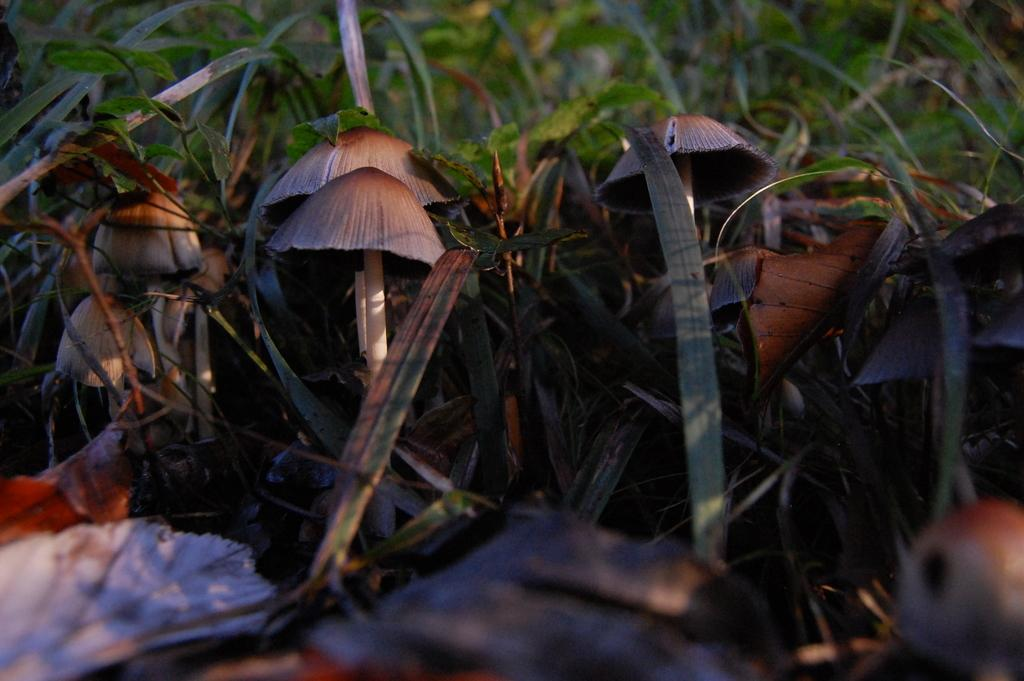What type of fungi can be seen in the image? There are mushrooms in the image. Where are the mushrooms located? The mushrooms are on a grassland. What type of ring can be seen on the mushrooms in the image? There is no ring present on the mushrooms in the image. Can you describe the honey that is being served with the mushrooms in the image? There is no honey present in the image; it only features mushrooms on a grassland. 